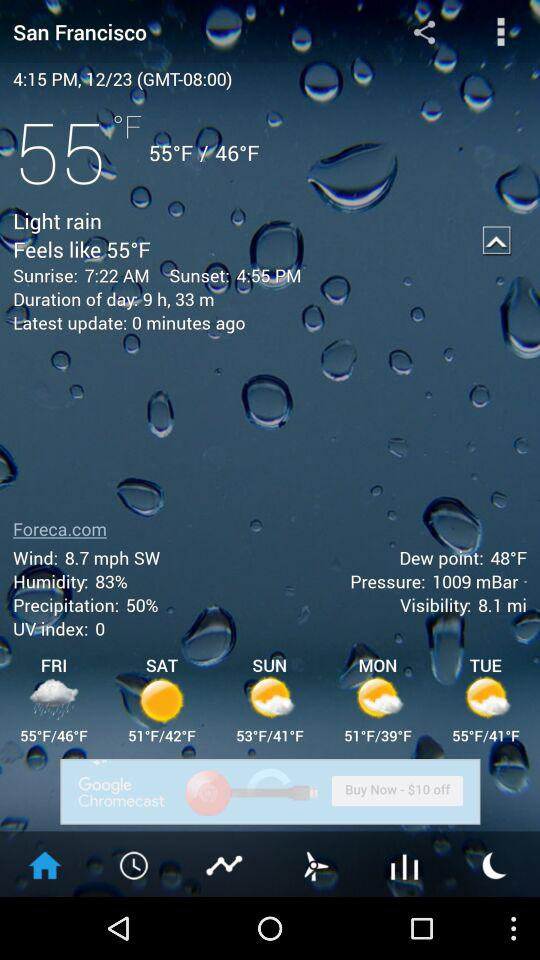What is the weather forecast for Monday? The weather is partially sunny and the maximum and minimum temperatures are 51 °F and 39 °F respectively. 